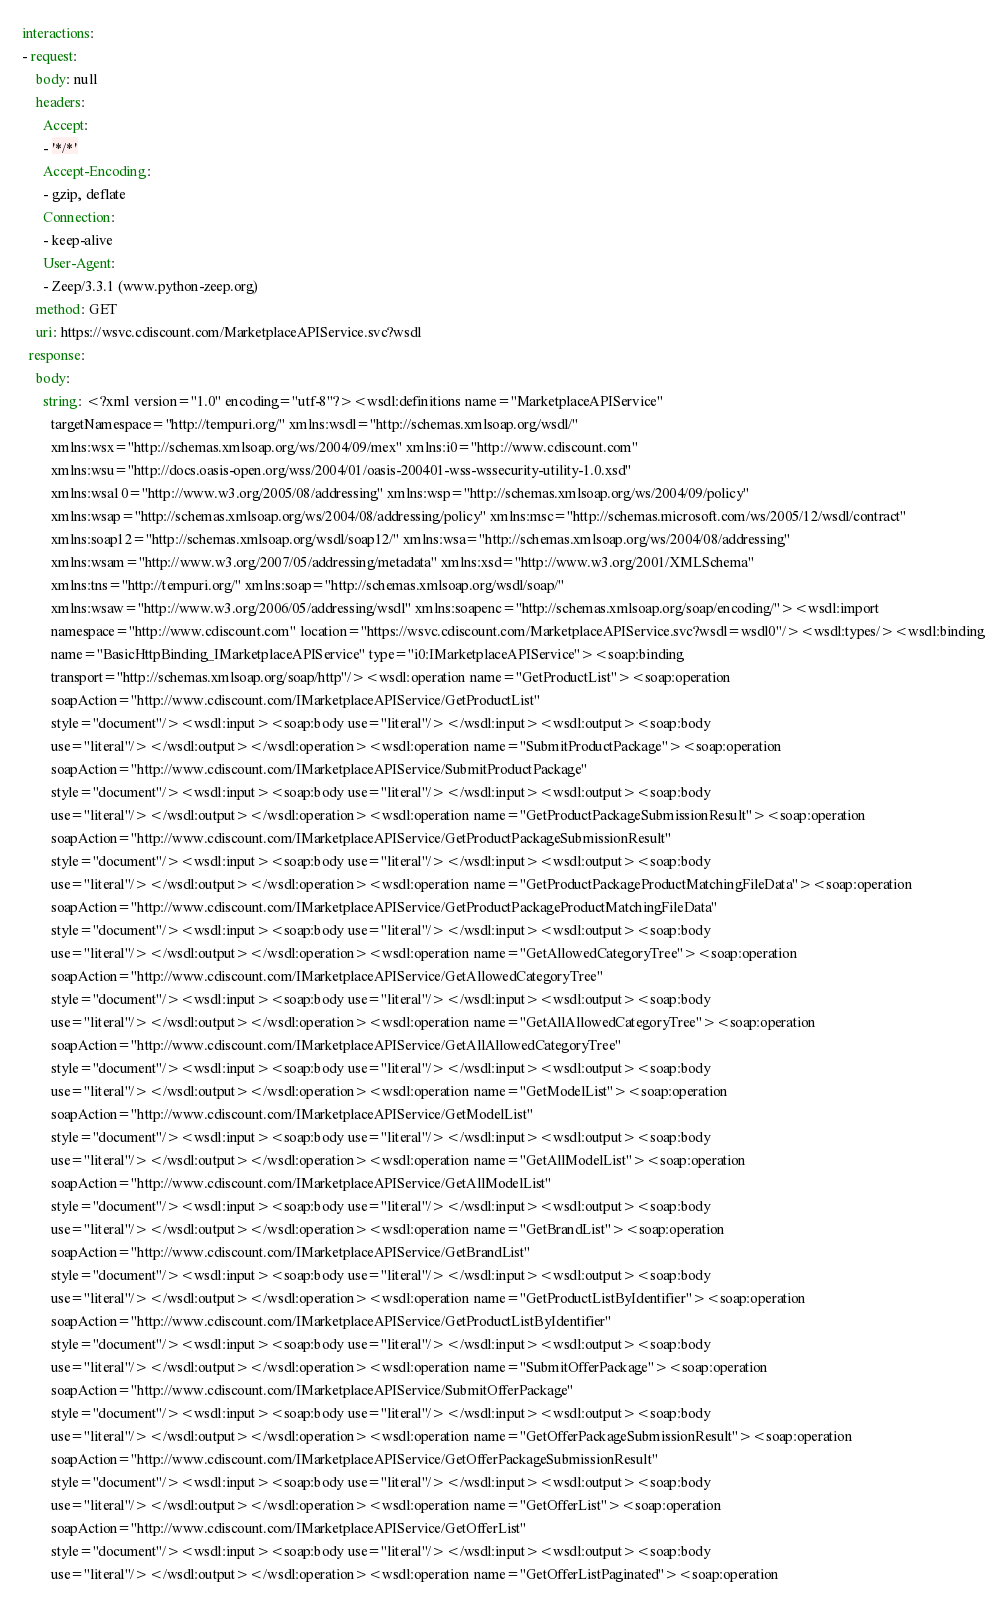<code> <loc_0><loc_0><loc_500><loc_500><_YAML_>interactions:
- request:
    body: null
    headers:
      Accept:
      - '*/*'
      Accept-Encoding:
      - gzip, deflate
      Connection:
      - keep-alive
      User-Agent:
      - Zeep/3.3.1 (www.python-zeep.org)
    method: GET
    uri: https://wsvc.cdiscount.com/MarketplaceAPIService.svc?wsdl
  response:
    body:
      string: <?xml version="1.0" encoding="utf-8"?><wsdl:definitions name="MarketplaceAPIService"
        targetNamespace="http://tempuri.org/" xmlns:wsdl="http://schemas.xmlsoap.org/wsdl/"
        xmlns:wsx="http://schemas.xmlsoap.org/ws/2004/09/mex" xmlns:i0="http://www.cdiscount.com"
        xmlns:wsu="http://docs.oasis-open.org/wss/2004/01/oasis-200401-wss-wssecurity-utility-1.0.xsd"
        xmlns:wsa10="http://www.w3.org/2005/08/addressing" xmlns:wsp="http://schemas.xmlsoap.org/ws/2004/09/policy"
        xmlns:wsap="http://schemas.xmlsoap.org/ws/2004/08/addressing/policy" xmlns:msc="http://schemas.microsoft.com/ws/2005/12/wsdl/contract"
        xmlns:soap12="http://schemas.xmlsoap.org/wsdl/soap12/" xmlns:wsa="http://schemas.xmlsoap.org/ws/2004/08/addressing"
        xmlns:wsam="http://www.w3.org/2007/05/addressing/metadata" xmlns:xsd="http://www.w3.org/2001/XMLSchema"
        xmlns:tns="http://tempuri.org/" xmlns:soap="http://schemas.xmlsoap.org/wsdl/soap/"
        xmlns:wsaw="http://www.w3.org/2006/05/addressing/wsdl" xmlns:soapenc="http://schemas.xmlsoap.org/soap/encoding/"><wsdl:import
        namespace="http://www.cdiscount.com" location="https://wsvc.cdiscount.com/MarketplaceAPIService.svc?wsdl=wsdl0"/><wsdl:types/><wsdl:binding
        name="BasicHttpBinding_IMarketplaceAPIService" type="i0:IMarketplaceAPIService"><soap:binding
        transport="http://schemas.xmlsoap.org/soap/http"/><wsdl:operation name="GetProductList"><soap:operation
        soapAction="http://www.cdiscount.com/IMarketplaceAPIService/GetProductList"
        style="document"/><wsdl:input><soap:body use="literal"/></wsdl:input><wsdl:output><soap:body
        use="literal"/></wsdl:output></wsdl:operation><wsdl:operation name="SubmitProductPackage"><soap:operation
        soapAction="http://www.cdiscount.com/IMarketplaceAPIService/SubmitProductPackage"
        style="document"/><wsdl:input><soap:body use="literal"/></wsdl:input><wsdl:output><soap:body
        use="literal"/></wsdl:output></wsdl:operation><wsdl:operation name="GetProductPackageSubmissionResult"><soap:operation
        soapAction="http://www.cdiscount.com/IMarketplaceAPIService/GetProductPackageSubmissionResult"
        style="document"/><wsdl:input><soap:body use="literal"/></wsdl:input><wsdl:output><soap:body
        use="literal"/></wsdl:output></wsdl:operation><wsdl:operation name="GetProductPackageProductMatchingFileData"><soap:operation
        soapAction="http://www.cdiscount.com/IMarketplaceAPIService/GetProductPackageProductMatchingFileData"
        style="document"/><wsdl:input><soap:body use="literal"/></wsdl:input><wsdl:output><soap:body
        use="literal"/></wsdl:output></wsdl:operation><wsdl:operation name="GetAllowedCategoryTree"><soap:operation
        soapAction="http://www.cdiscount.com/IMarketplaceAPIService/GetAllowedCategoryTree"
        style="document"/><wsdl:input><soap:body use="literal"/></wsdl:input><wsdl:output><soap:body
        use="literal"/></wsdl:output></wsdl:operation><wsdl:operation name="GetAllAllowedCategoryTree"><soap:operation
        soapAction="http://www.cdiscount.com/IMarketplaceAPIService/GetAllAllowedCategoryTree"
        style="document"/><wsdl:input><soap:body use="literal"/></wsdl:input><wsdl:output><soap:body
        use="literal"/></wsdl:output></wsdl:operation><wsdl:operation name="GetModelList"><soap:operation
        soapAction="http://www.cdiscount.com/IMarketplaceAPIService/GetModelList"
        style="document"/><wsdl:input><soap:body use="literal"/></wsdl:input><wsdl:output><soap:body
        use="literal"/></wsdl:output></wsdl:operation><wsdl:operation name="GetAllModelList"><soap:operation
        soapAction="http://www.cdiscount.com/IMarketplaceAPIService/GetAllModelList"
        style="document"/><wsdl:input><soap:body use="literal"/></wsdl:input><wsdl:output><soap:body
        use="literal"/></wsdl:output></wsdl:operation><wsdl:operation name="GetBrandList"><soap:operation
        soapAction="http://www.cdiscount.com/IMarketplaceAPIService/GetBrandList"
        style="document"/><wsdl:input><soap:body use="literal"/></wsdl:input><wsdl:output><soap:body
        use="literal"/></wsdl:output></wsdl:operation><wsdl:operation name="GetProductListByIdentifier"><soap:operation
        soapAction="http://www.cdiscount.com/IMarketplaceAPIService/GetProductListByIdentifier"
        style="document"/><wsdl:input><soap:body use="literal"/></wsdl:input><wsdl:output><soap:body
        use="literal"/></wsdl:output></wsdl:operation><wsdl:operation name="SubmitOfferPackage"><soap:operation
        soapAction="http://www.cdiscount.com/IMarketplaceAPIService/SubmitOfferPackage"
        style="document"/><wsdl:input><soap:body use="literal"/></wsdl:input><wsdl:output><soap:body
        use="literal"/></wsdl:output></wsdl:operation><wsdl:operation name="GetOfferPackageSubmissionResult"><soap:operation
        soapAction="http://www.cdiscount.com/IMarketplaceAPIService/GetOfferPackageSubmissionResult"
        style="document"/><wsdl:input><soap:body use="literal"/></wsdl:input><wsdl:output><soap:body
        use="literal"/></wsdl:output></wsdl:operation><wsdl:operation name="GetOfferList"><soap:operation
        soapAction="http://www.cdiscount.com/IMarketplaceAPIService/GetOfferList"
        style="document"/><wsdl:input><soap:body use="literal"/></wsdl:input><wsdl:output><soap:body
        use="literal"/></wsdl:output></wsdl:operation><wsdl:operation name="GetOfferListPaginated"><soap:operation</code> 